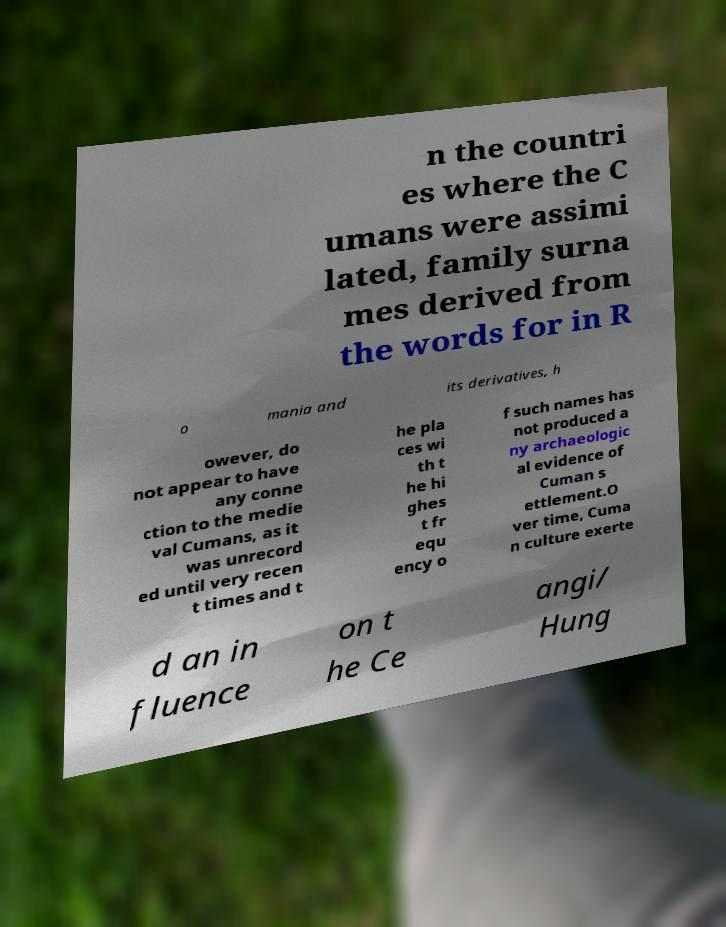What messages or text are displayed in this image? I need them in a readable, typed format. n the countri es where the C umans were assimi lated, family surna mes derived from the words for in R o mania and its derivatives, h owever, do not appear to have any conne ction to the medie val Cumans, as it was unrecord ed until very recen t times and t he pla ces wi th t he hi ghes t fr equ ency o f such names has not produced a ny archaeologic al evidence of Cuman s ettlement.O ver time, Cuma n culture exerte d an in fluence on t he Ce angi/ Hung 